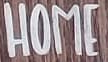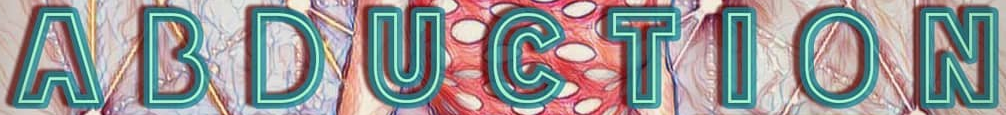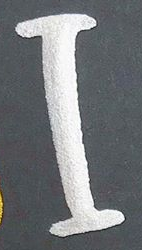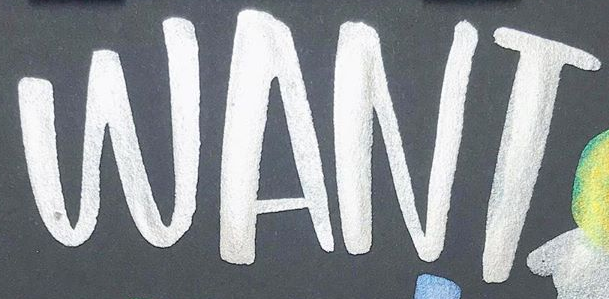Identify the words shown in these images in order, separated by a semicolon. HOME; ABDUCTION; I; WANT 